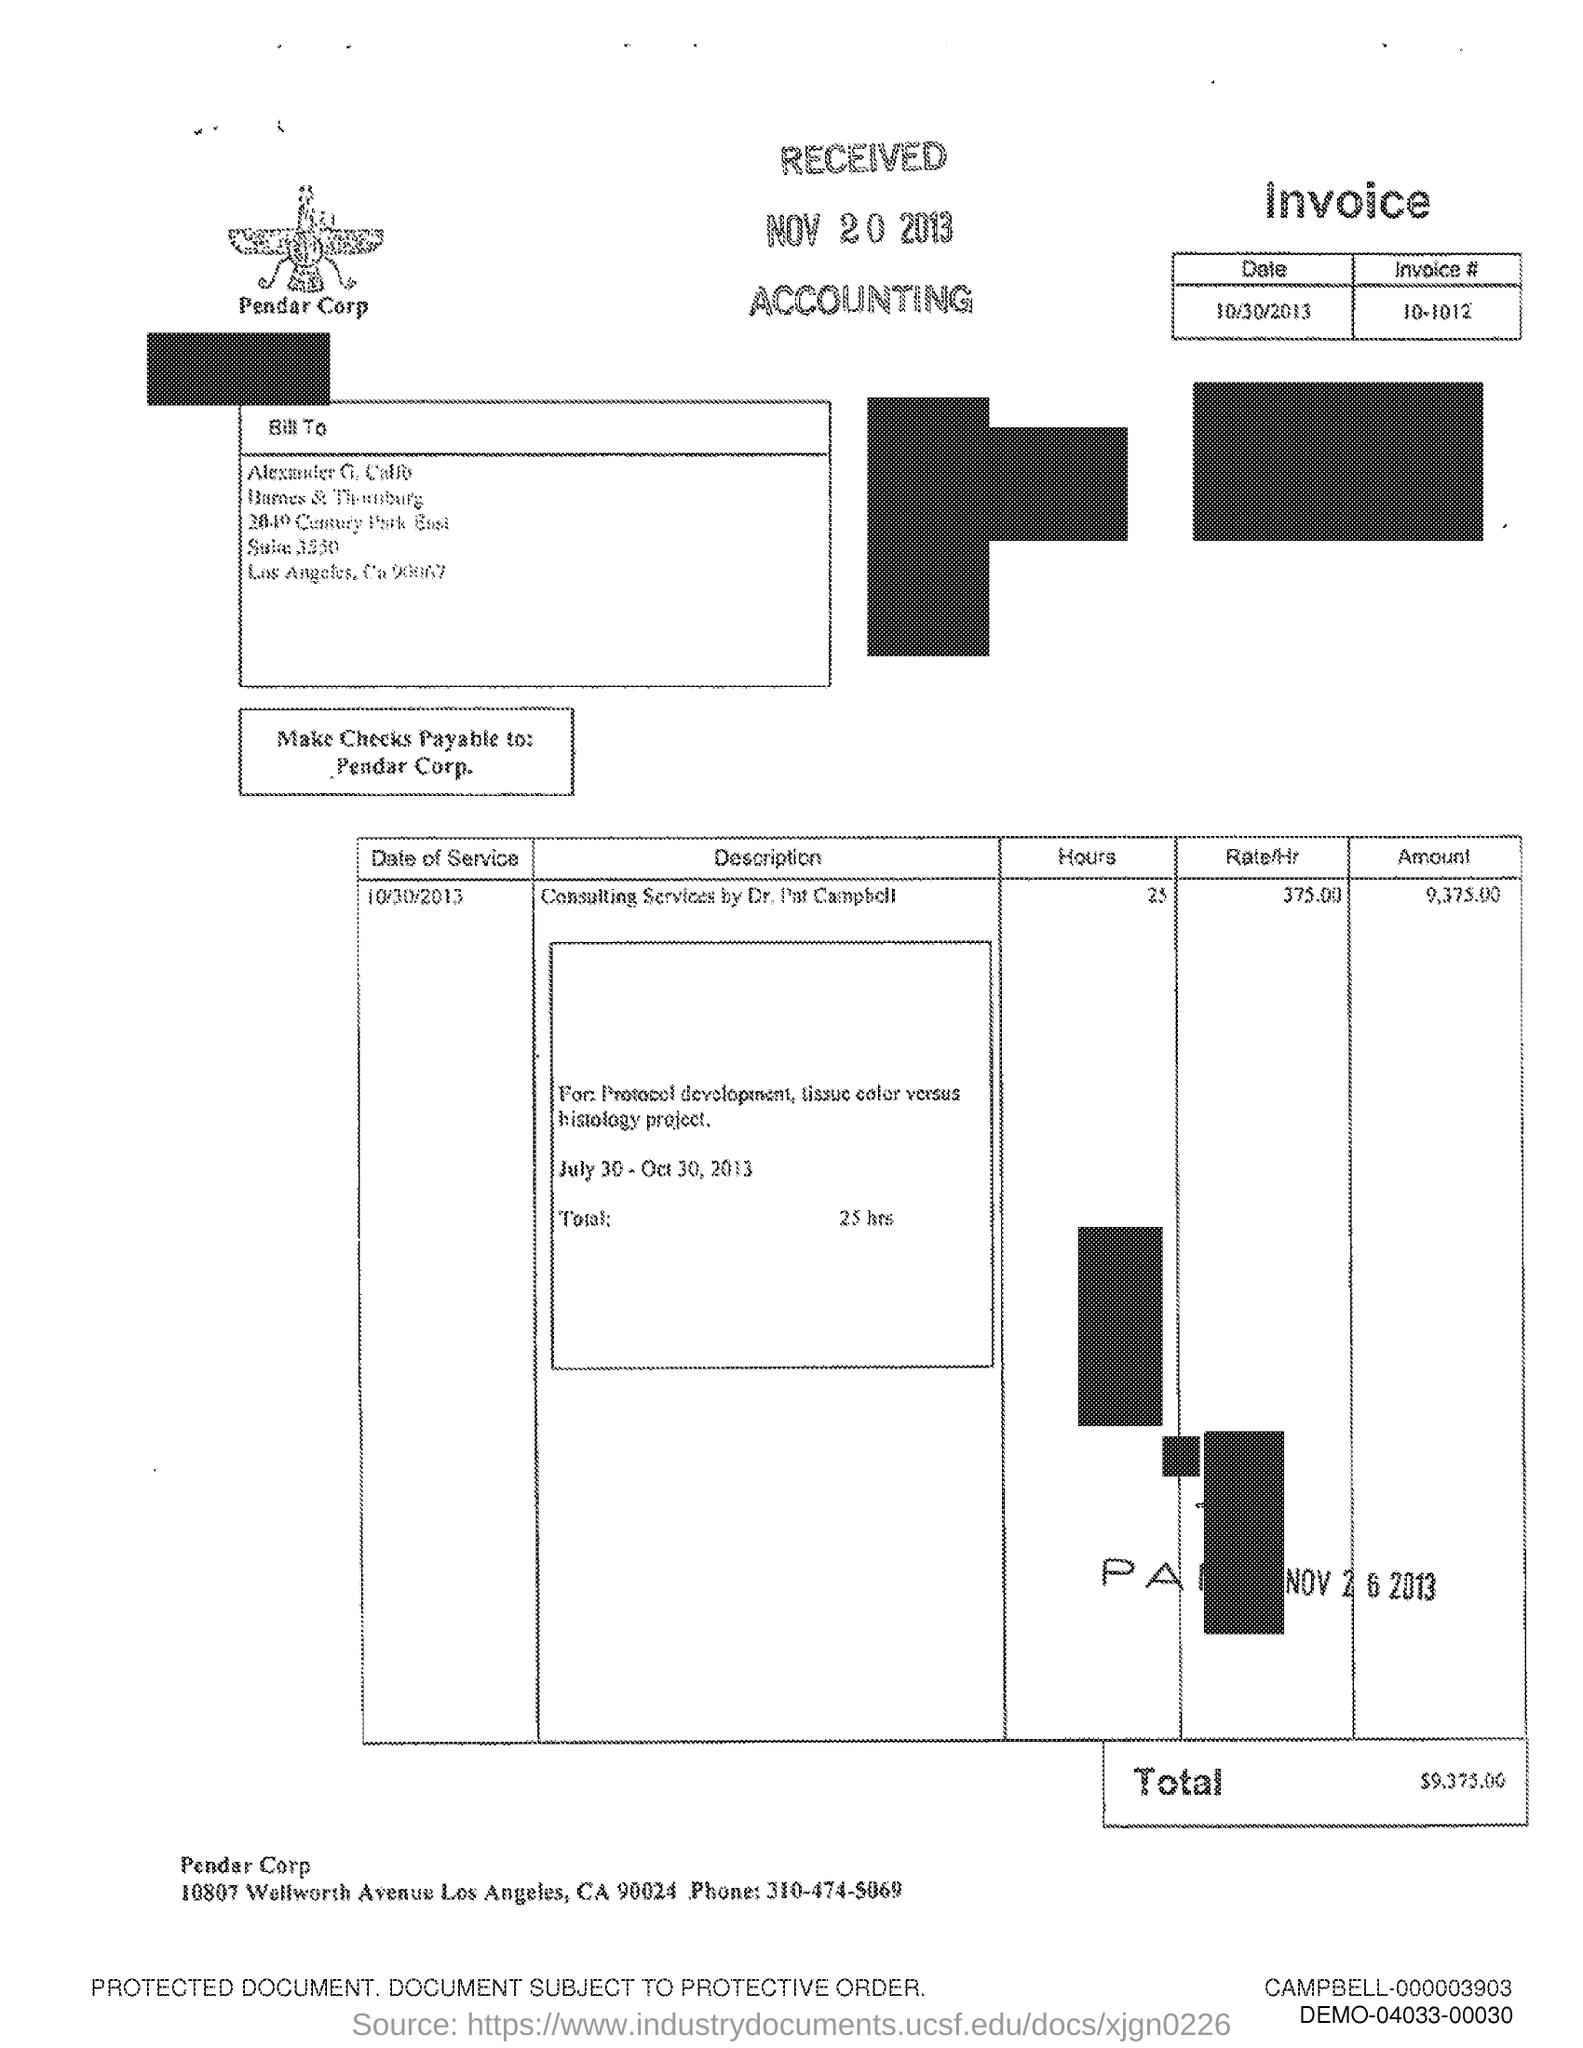What is the phone number mentioned in the document?
Provide a short and direct response. 310-474-5069. What is the text written below the image?
Your answer should be very brief. Pendar Corp. 